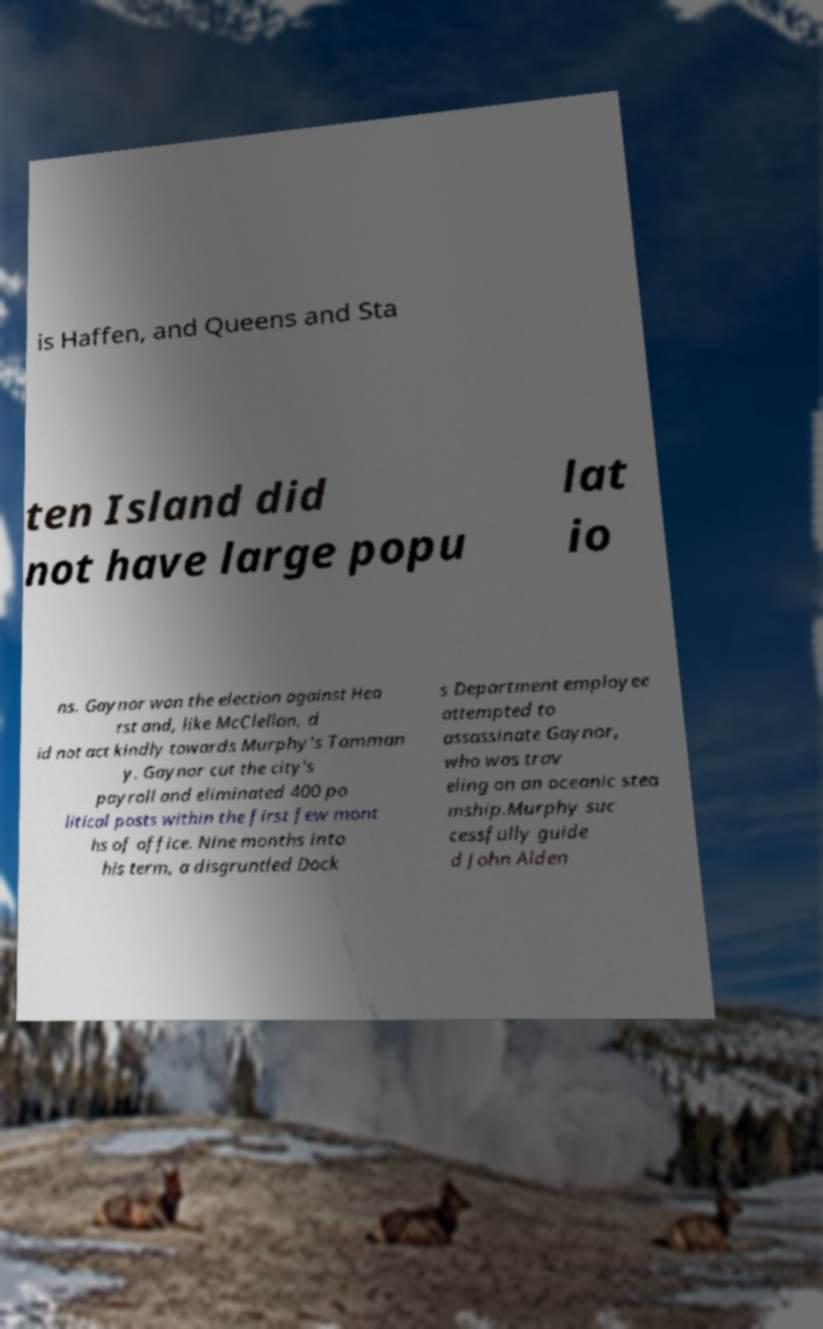I need the written content from this picture converted into text. Can you do that? is Haffen, and Queens and Sta ten Island did not have large popu lat io ns. Gaynor won the election against Hea rst and, like McClellan, d id not act kindly towards Murphy's Tamman y. Gaynor cut the city's payroll and eliminated 400 po litical posts within the first few mont hs of office. Nine months into his term, a disgruntled Dock s Department employee attempted to assassinate Gaynor, who was trav eling on an oceanic stea mship.Murphy suc cessfully guide d John Alden 